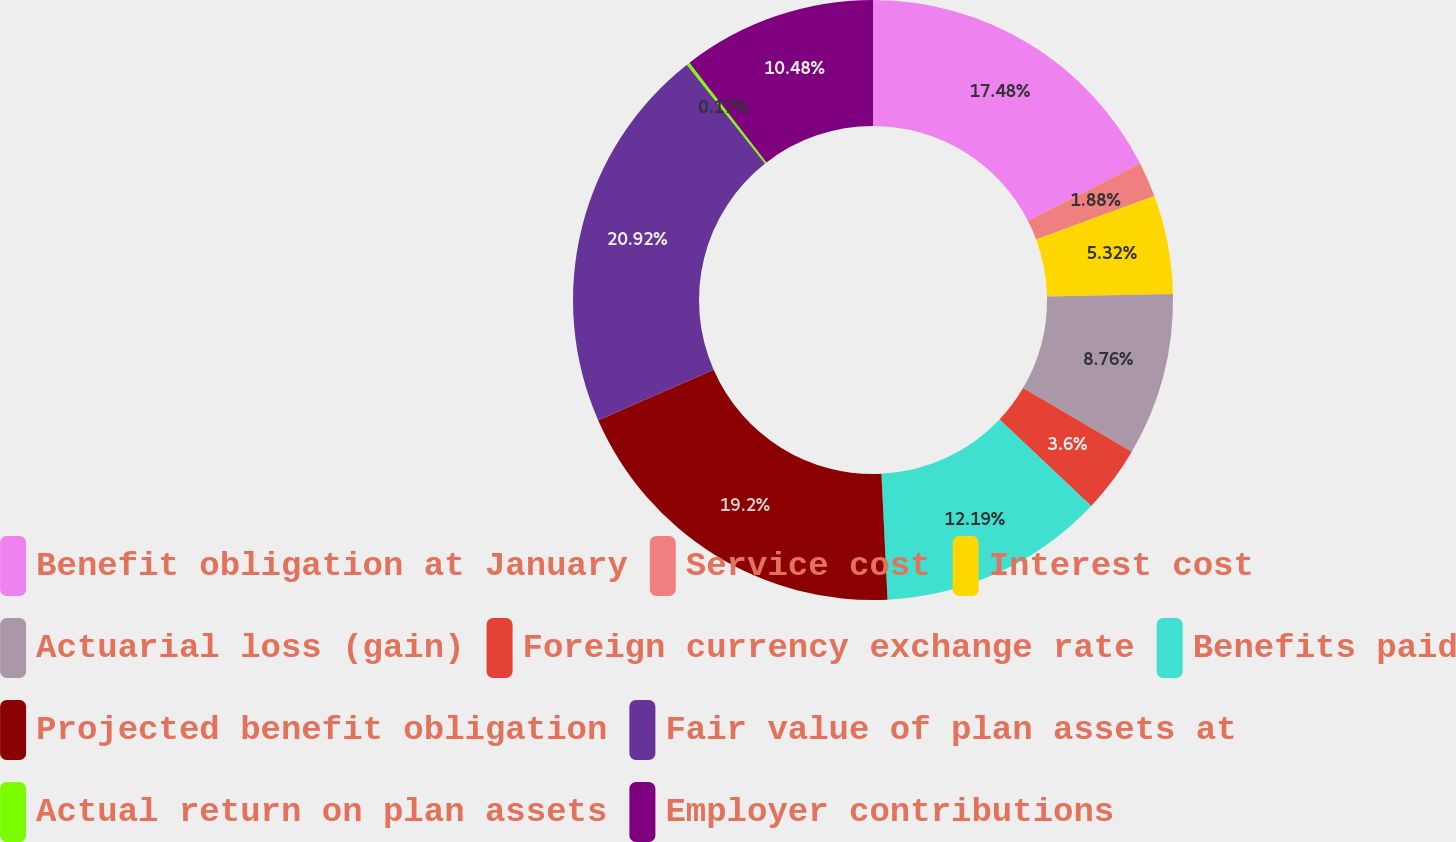<chart> <loc_0><loc_0><loc_500><loc_500><pie_chart><fcel>Benefit obligation at January<fcel>Service cost<fcel>Interest cost<fcel>Actuarial loss (gain)<fcel>Foreign currency exchange rate<fcel>Benefits paid<fcel>Projected benefit obligation<fcel>Fair value of plan assets at<fcel>Actual return on plan assets<fcel>Employer contributions<nl><fcel>17.48%<fcel>1.88%<fcel>5.32%<fcel>8.76%<fcel>3.6%<fcel>12.19%<fcel>19.2%<fcel>20.92%<fcel>0.17%<fcel>10.48%<nl></chart> 